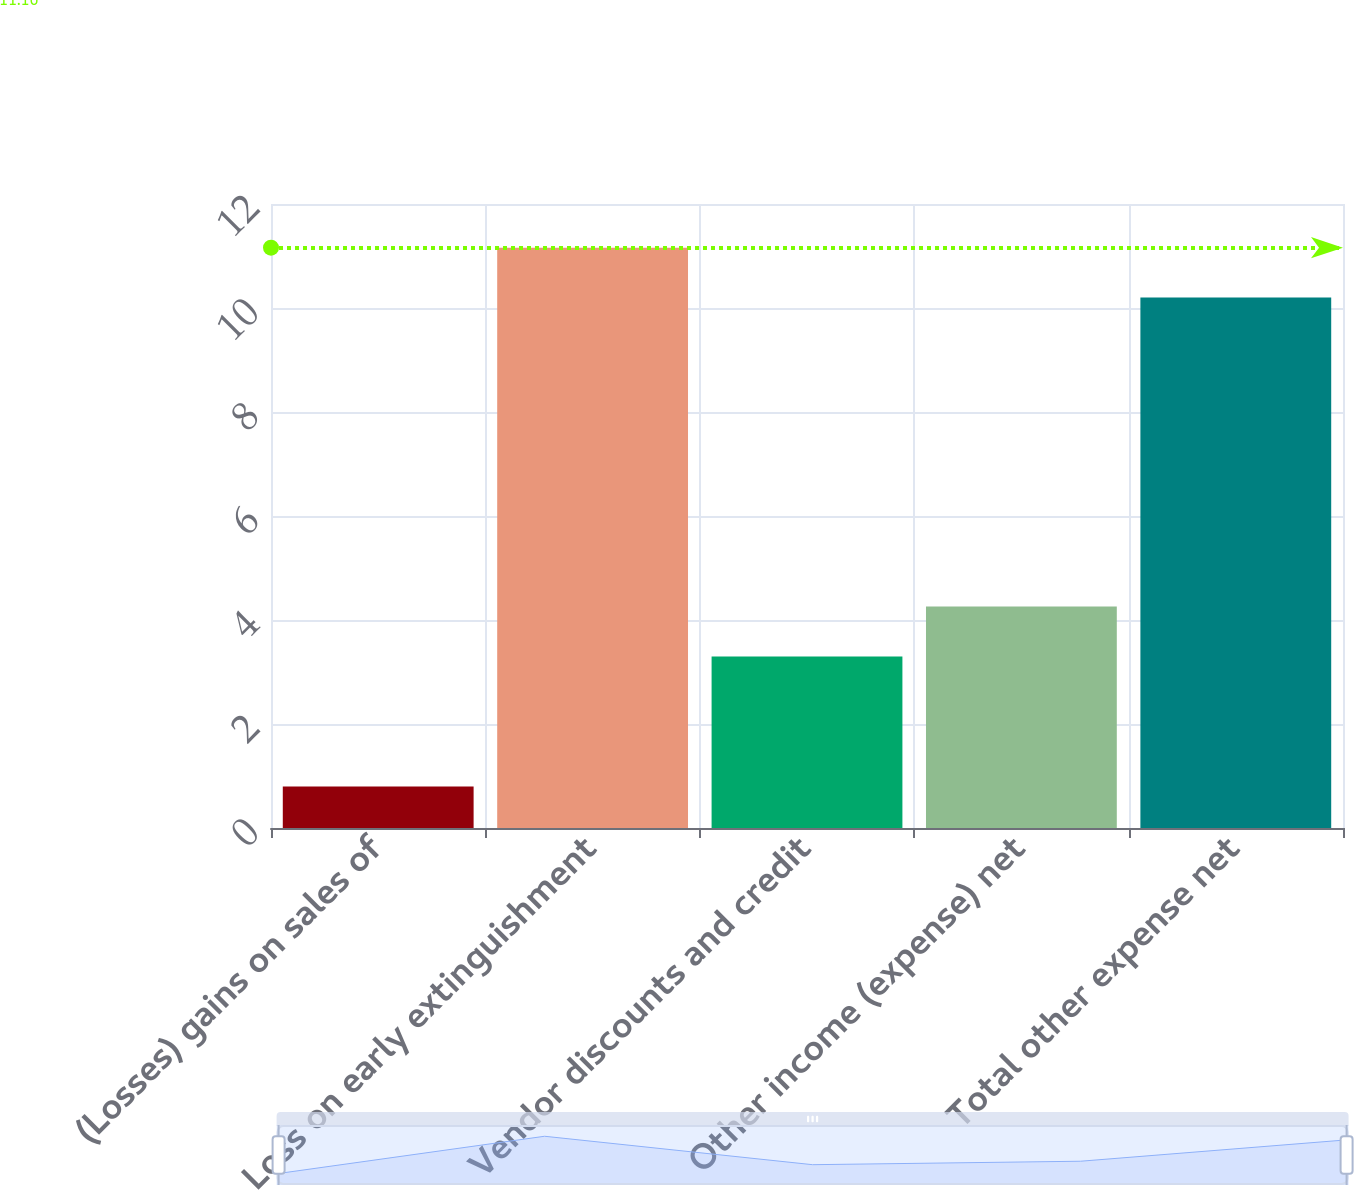<chart> <loc_0><loc_0><loc_500><loc_500><bar_chart><fcel>(Losses) gains on sales of<fcel>Loss on early extinguishment<fcel>Vendor discounts and credit<fcel>Other income (expense) net<fcel>Total other expense net<nl><fcel>0.8<fcel>11.16<fcel>3.3<fcel>4.26<fcel>10.2<nl></chart> 